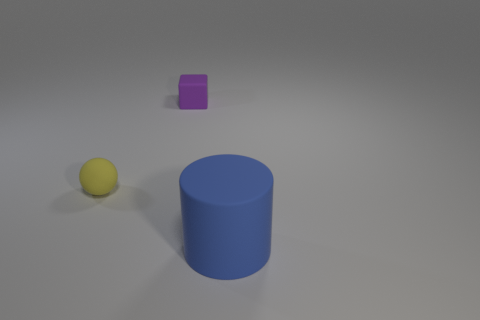Add 3 blue rubber things. How many objects exist? 6 Subtract all cubes. How many objects are left? 2 Add 3 purple cubes. How many purple cubes are left? 4 Add 1 small purple rubber blocks. How many small purple rubber blocks exist? 2 Subtract 0 green cubes. How many objects are left? 3 Subtract all red blocks. Subtract all green cylinders. How many blocks are left? 1 Subtract all small green objects. Subtract all tiny yellow rubber objects. How many objects are left? 2 